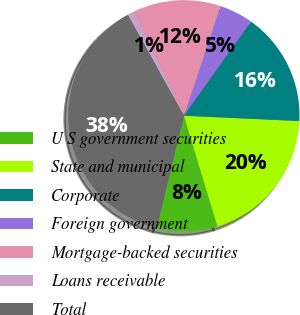<chart> <loc_0><loc_0><loc_500><loc_500><pie_chart><fcel>U S government securities<fcel>State and municipal<fcel>Corporate<fcel>Foreign government<fcel>Mortgage-backed securities<fcel>Loans receivable<fcel>Total<nl><fcel>8.45%<fcel>19.59%<fcel>15.88%<fcel>4.74%<fcel>12.17%<fcel>1.03%<fcel>38.14%<nl></chart> 